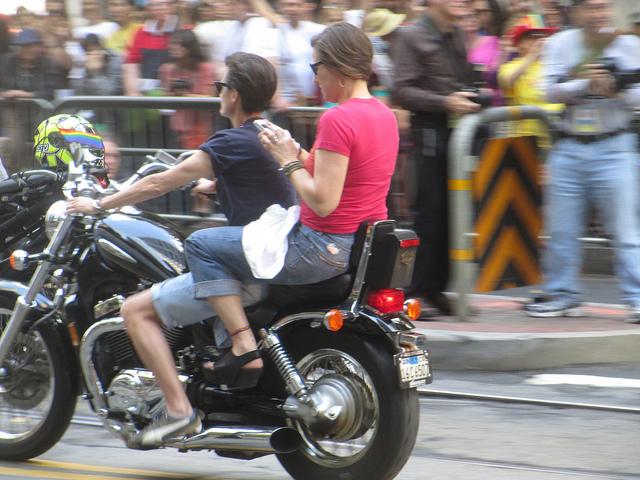What color is the motorcycle?
Write a very short answer. Black. Is he wearing a helmet?
Write a very short answer. No. How many people are on the motorcycle?
Quick response, please. 2. Is the woman texting?
Quick response, please. Yes. Where are they driving too in the motorcycle?
Short answer required. Forward. 